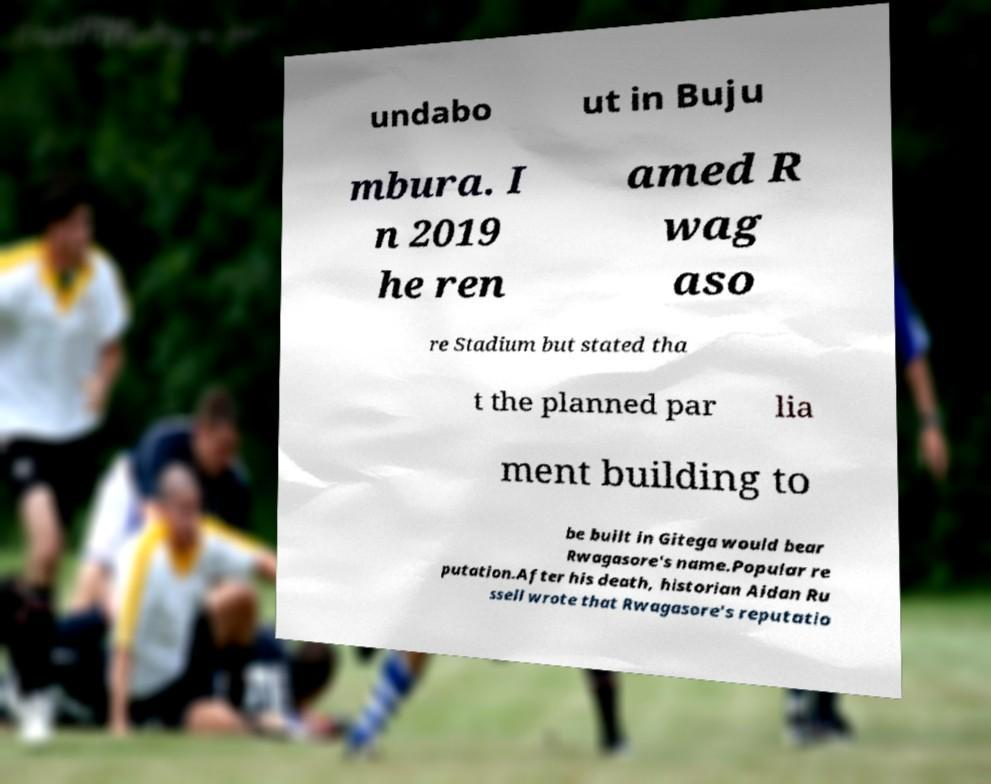Please identify and transcribe the text found in this image. undabo ut in Buju mbura. I n 2019 he ren amed R wag aso re Stadium but stated tha t the planned par lia ment building to be built in Gitega would bear Rwagasore's name.Popular re putation.After his death, historian Aidan Ru ssell wrote that Rwagasore's reputatio 